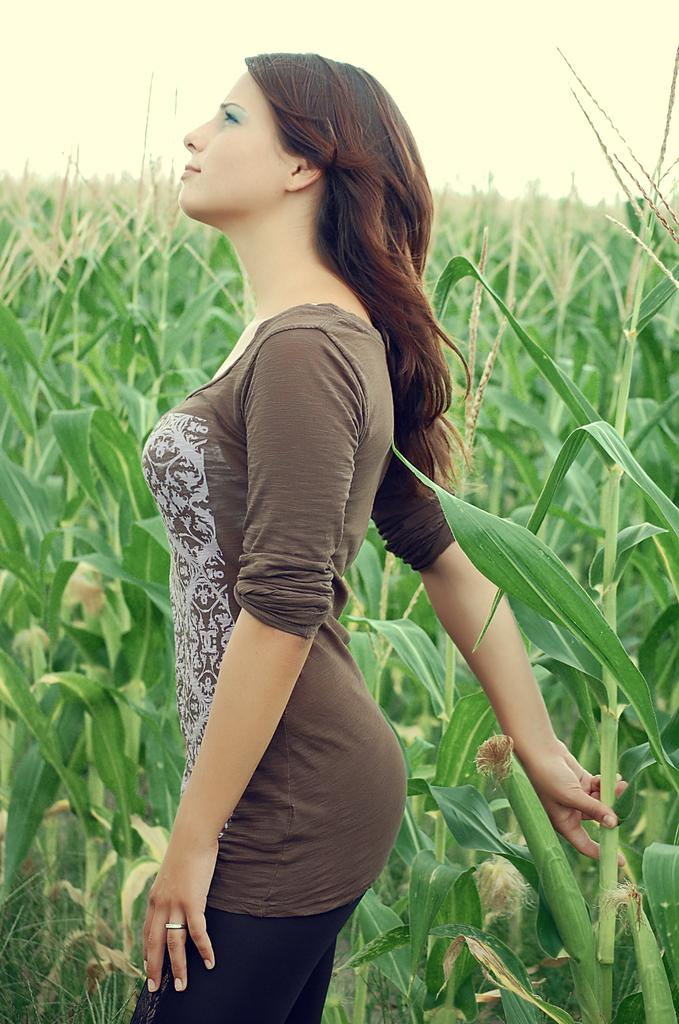Who is the main subject in the image? There is a woman in the center of the image. What is the woman wearing? The woman is wearing a t-shirt. What is the woman holding in the image? The woman is holding a stem. What is the woman's posture in the image? The woman is standing. What can be seen in the background of the image? There is sky and plants visible in the background of the image. What type of bomb can be seen in the woman's hand in the image? There is no bomb present in the image; the woman is holding a stem. What is the woman writing on the stem in the image? There is no writing or indication of writing on the stem in the image. 